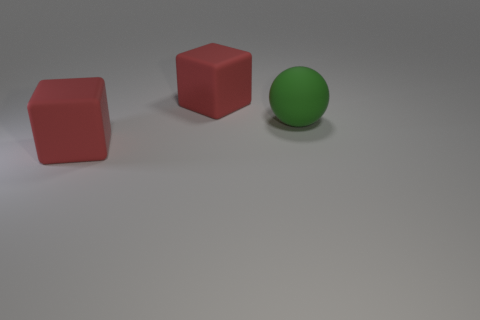Add 1 large matte blocks. How many objects exist? 4 Subtract all cubes. How many objects are left? 1 Subtract all large matte blocks. Subtract all green rubber things. How many objects are left? 0 Add 2 big rubber spheres. How many big rubber spheres are left? 3 Add 1 red things. How many red things exist? 3 Subtract 0 red cylinders. How many objects are left? 3 